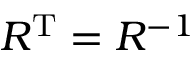<formula> <loc_0><loc_0><loc_500><loc_500>R ^ { T } = R ^ { - 1 }</formula> 